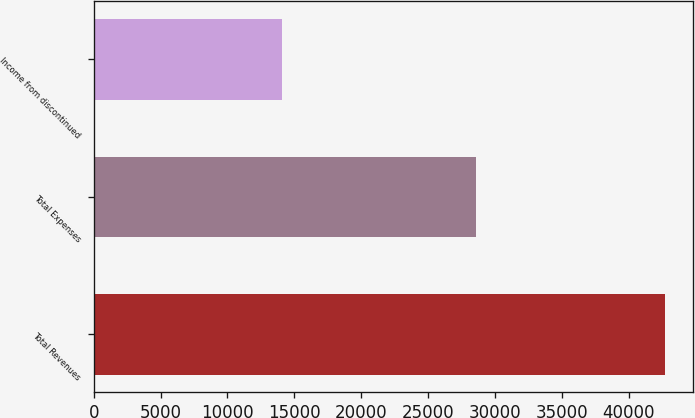Convert chart. <chart><loc_0><loc_0><loc_500><loc_500><bar_chart><fcel>Total Revenues<fcel>Total Expenses<fcel>Income from discontinued<nl><fcel>42694<fcel>28621<fcel>14073<nl></chart> 